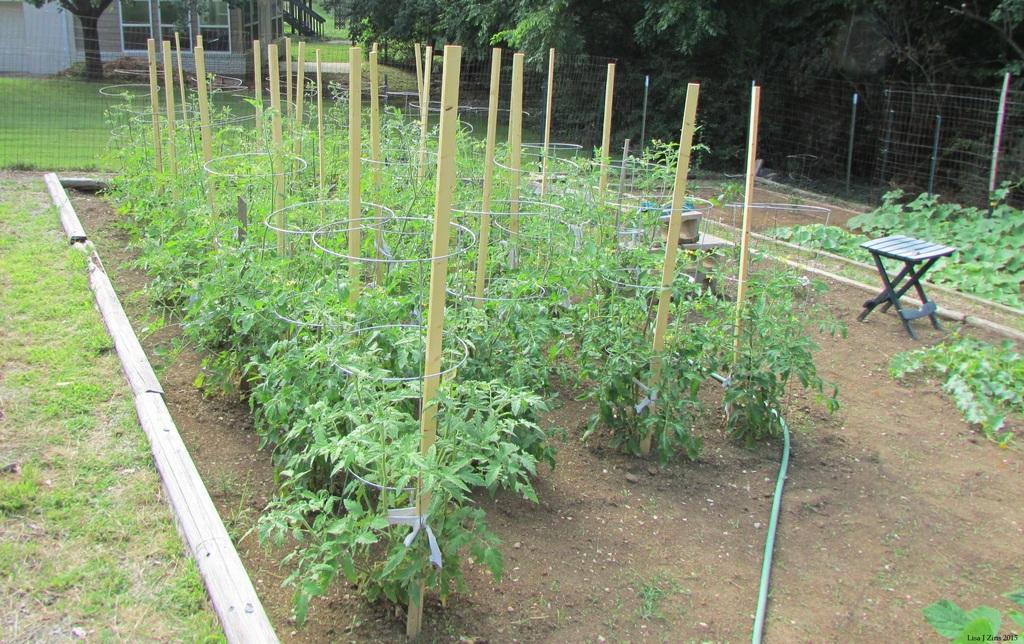What type of plants are in the image? There are plants with iron wires and wooden sticks in the image. What other objects can be seen in the image? There is a pipe, a stool, and a watermark on the image. What is visible in the background of the image? There are trees, a wire fence, and a house in the background of the image. How many oranges and apples are on the stool in the image? There are no oranges or apples present in the image; the stool is empty. 